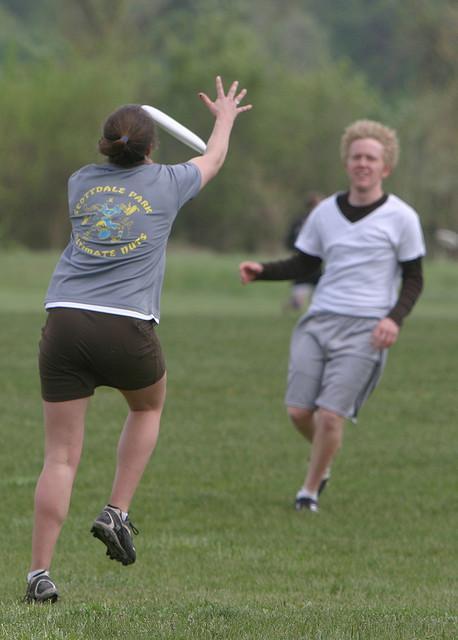How many people are playing frisbee?
Give a very brief answer. 2. How many people are playing?
Give a very brief answer. 2. How many women are there?
Give a very brief answer. 1. How many of the women have stripes on their pants?
Give a very brief answer. 1. How many people are in the picture?
Give a very brief answer. 2. 